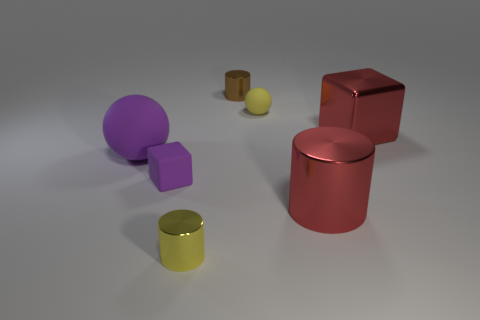Is the small brown thing the same shape as the yellow metal object?
Ensure brevity in your answer.  Yes. There is a tiny thing that is the same shape as the big rubber thing; what material is it?
Provide a short and direct response. Rubber. What is the material of the yellow object that is the same size as the yellow cylinder?
Your response must be concise. Rubber. What number of brown objects are either tiny metallic objects or small cubes?
Provide a short and direct response. 1. What color is the cylinder that is in front of the brown metallic cylinder and behind the small yellow metal cylinder?
Provide a succinct answer. Red. Is the ball that is to the right of the matte cube made of the same material as the big red thing that is in front of the purple rubber cube?
Your answer should be compact. No. Is the number of red cylinders in front of the tiny yellow rubber object greater than the number of big metallic objects left of the small yellow metal cylinder?
Provide a short and direct response. Yes. There is a yellow matte thing that is the same size as the purple block; what is its shape?
Your answer should be compact. Sphere. What number of objects are either small cylinders or rubber objects that are left of the small yellow rubber sphere?
Offer a very short reply. 4. Is the metallic block the same color as the large shiny cylinder?
Provide a succinct answer. Yes. 